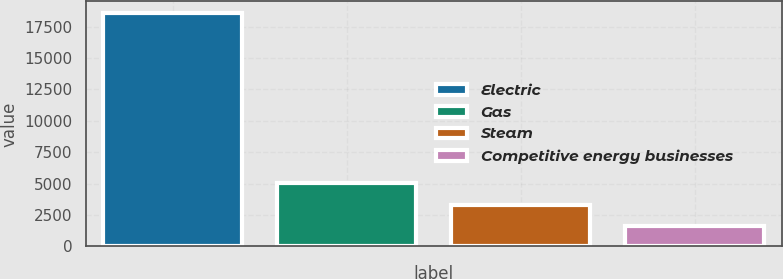Convert chart to OTSL. <chart><loc_0><loc_0><loc_500><loc_500><bar_chart><fcel>Electric<fcel>Gas<fcel>Steam<fcel>Competitive energy businesses<nl><fcel>18581<fcel>5019.4<fcel>3324.2<fcel>1629<nl></chart> 